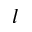<formula> <loc_0><loc_0><loc_500><loc_500>l</formula> 